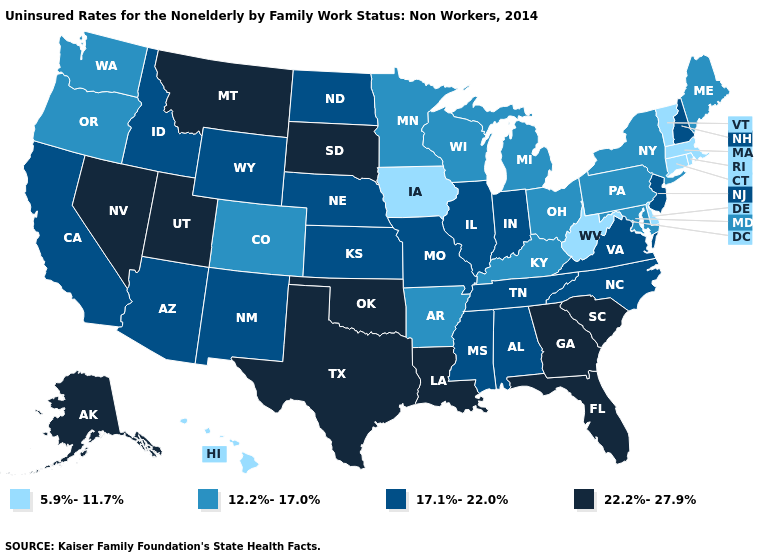What is the value of Texas?
Concise answer only. 22.2%-27.9%. Name the states that have a value in the range 22.2%-27.9%?
Short answer required. Alaska, Florida, Georgia, Louisiana, Montana, Nevada, Oklahoma, South Carolina, South Dakota, Texas, Utah. Does Iowa have a lower value than Washington?
Keep it brief. Yes. What is the highest value in states that border Indiana?
Write a very short answer. 17.1%-22.0%. Does Delaware have the lowest value in the USA?
Quick response, please. Yes. What is the highest value in the USA?
Concise answer only. 22.2%-27.9%. What is the value of Delaware?
Give a very brief answer. 5.9%-11.7%. Name the states that have a value in the range 22.2%-27.9%?
Give a very brief answer. Alaska, Florida, Georgia, Louisiana, Montana, Nevada, Oklahoma, South Carolina, South Dakota, Texas, Utah. What is the value of Alabama?
Quick response, please. 17.1%-22.0%. Does Nebraska have a higher value than Alabama?
Write a very short answer. No. What is the value of South Dakota?
Give a very brief answer. 22.2%-27.9%. Name the states that have a value in the range 5.9%-11.7%?
Quick response, please. Connecticut, Delaware, Hawaii, Iowa, Massachusetts, Rhode Island, Vermont, West Virginia. What is the lowest value in states that border Connecticut?
Answer briefly. 5.9%-11.7%. Name the states that have a value in the range 17.1%-22.0%?
Answer briefly. Alabama, Arizona, California, Idaho, Illinois, Indiana, Kansas, Mississippi, Missouri, Nebraska, New Hampshire, New Jersey, New Mexico, North Carolina, North Dakota, Tennessee, Virginia, Wyoming. What is the lowest value in the MidWest?
Concise answer only. 5.9%-11.7%. 